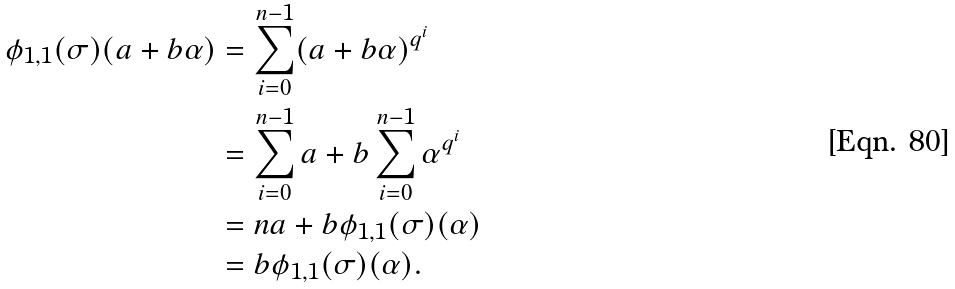Convert formula to latex. <formula><loc_0><loc_0><loc_500><loc_500>\phi _ { 1 , { 1 } } ( \sigma ) ( a + b \alpha ) & = \sum _ { i = 0 } ^ { n - 1 } ( a + b \alpha ) ^ { q ^ { i } } \\ & = \sum _ { i = 0 } ^ { n - 1 } a + b \sum _ { i = 0 } ^ { n - 1 } \alpha ^ { q ^ { i } } \\ & = n a + b \phi _ { 1 , { 1 } } ( \sigma ) ( \alpha ) \\ & = b \phi _ { 1 , { 1 } } ( \sigma ) ( \alpha ) .</formula> 